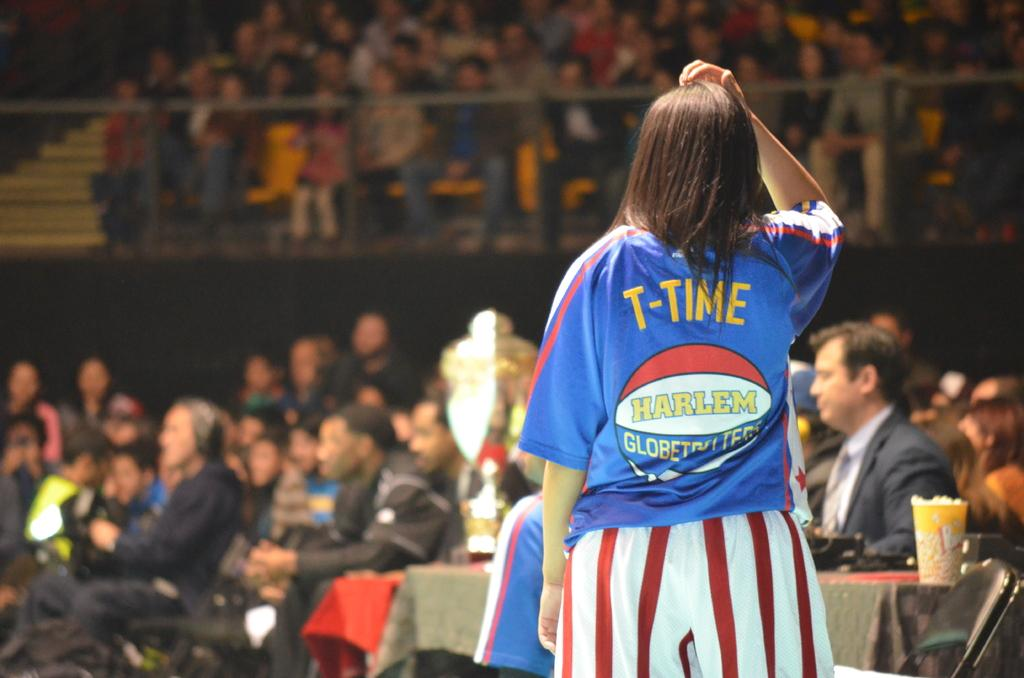Provide a one-sentence caption for the provided image. A women standing with the name T-Time on her back. 